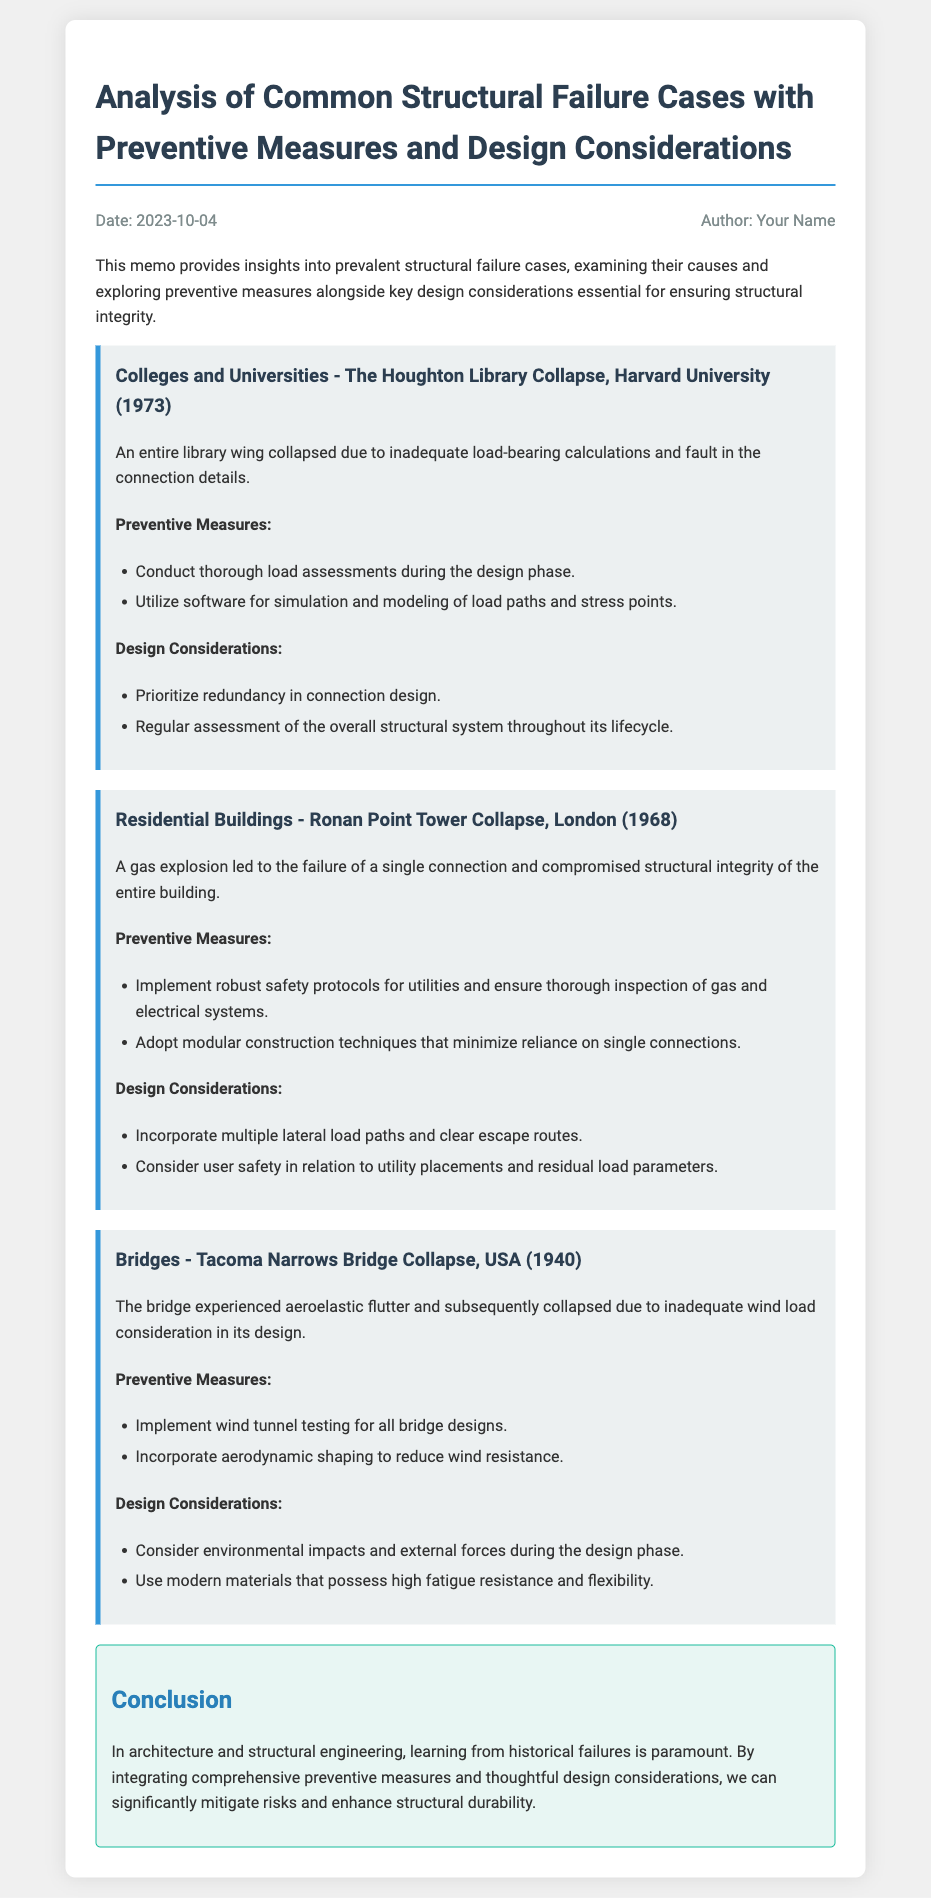what is the date of the memo? The date of the memo is found in the meta section, indicating when it was written.
Answer: 2023-10-04 who is the author of the memo? The author is mentioned in the meta section of the document.
Answer: Your Name what structural failure case occurred at Harvard University? It is listed in the document with the specific case mentioned.
Answer: The Houghton Library Collapse what was a cause of the Ronan Point Tower Collapse? The specific cause is stated in the section describing the case.
Answer: A gas explosion what type of testing is recommended for bridge designs? This is referenced under preventive measures for the Tacoma Narrows Bridge collapse.
Answer: Wind tunnel testing which design consideration is highlighted for residential buildings? This is mentioned in the design considerations section focusing on residential safety.
Answer: Incorporate multiple lateral load paths what lesson is emphasized in the conclusion of the memo? The conclusion summarizes the key takeaway regarding structural integrity.
Answer: Learning from historical failures what year did the Tacoma Narrows Bridge collapse occur? The year is mentioned in the title of the case.
Answer: 1940 how many preventive measures are listed for the Houghton Library Collapse? The number of measures can be counted in the preventive measures section.
Answer: Two 